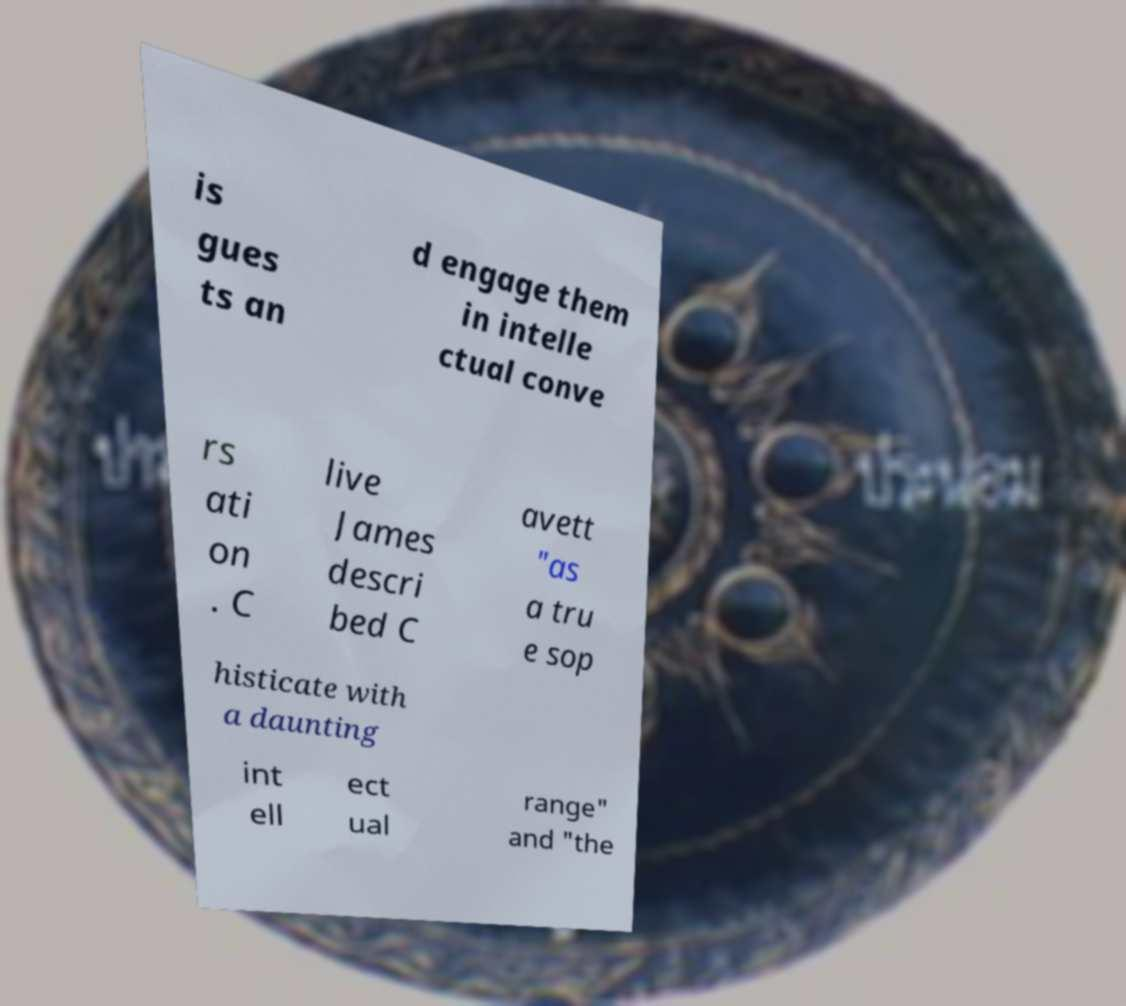Please identify and transcribe the text found in this image. is gues ts an d engage them in intelle ctual conve rs ati on . C live James descri bed C avett "as a tru e sop histicate with a daunting int ell ect ual range" and "the 